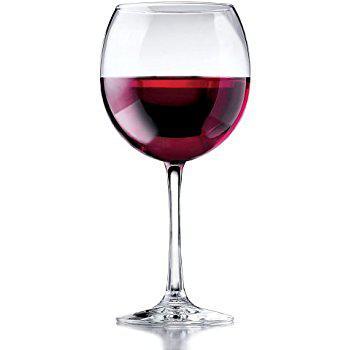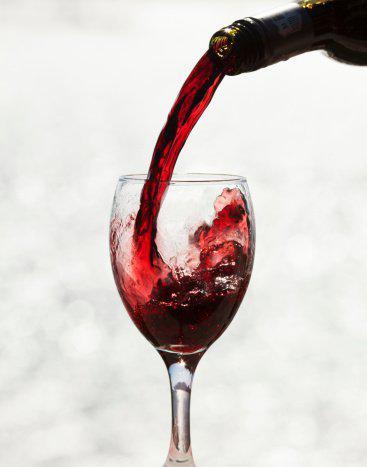The first image is the image on the left, the second image is the image on the right. Evaluate the accuracy of this statement regarding the images: "There are four wine glasses, and some of them are in front of the others.". Is it true? Answer yes or no. No. The first image is the image on the left, the second image is the image on the right. Assess this claim about the two images: "There are more than two glasses with wine in them". Correct or not? Answer yes or no. No. 